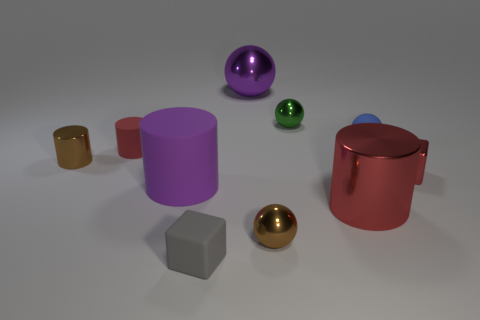Does the large cylinder that is on the left side of the large metallic sphere have the same material as the tiny cube that is right of the tiny blue thing?
Provide a short and direct response. No. What material is the red block?
Offer a terse response. Metal. How many tiny rubber objects are the same shape as the small red metallic object?
Offer a terse response. 1. What material is the big ball that is the same color as the big matte cylinder?
Provide a succinct answer. Metal. Is there anything else that is the same shape as the blue matte thing?
Your response must be concise. Yes. The big cylinder on the left side of the small brown shiny object on the right side of the red cylinder on the left side of the purple shiny sphere is what color?
Offer a terse response. Purple. How many large things are either matte blocks or red matte things?
Offer a terse response. 0. Are there the same number of red metal blocks that are behind the brown metal ball and large gray matte blocks?
Provide a succinct answer. No. Are there any brown metallic spheres left of the purple matte cylinder?
Provide a short and direct response. No. What number of metal objects are either small red things or tiny brown cylinders?
Ensure brevity in your answer.  2. 